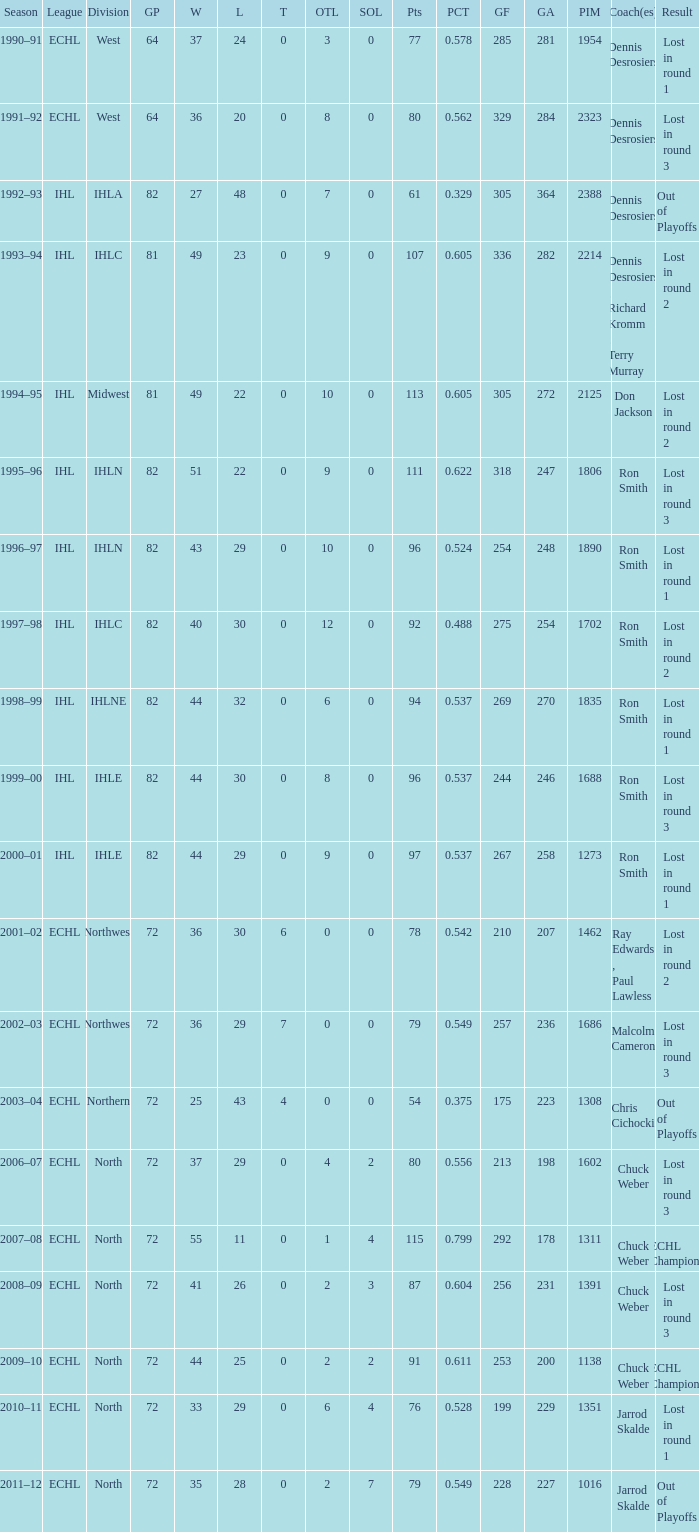What was the minimum L if the GA is 272? 22.0. 